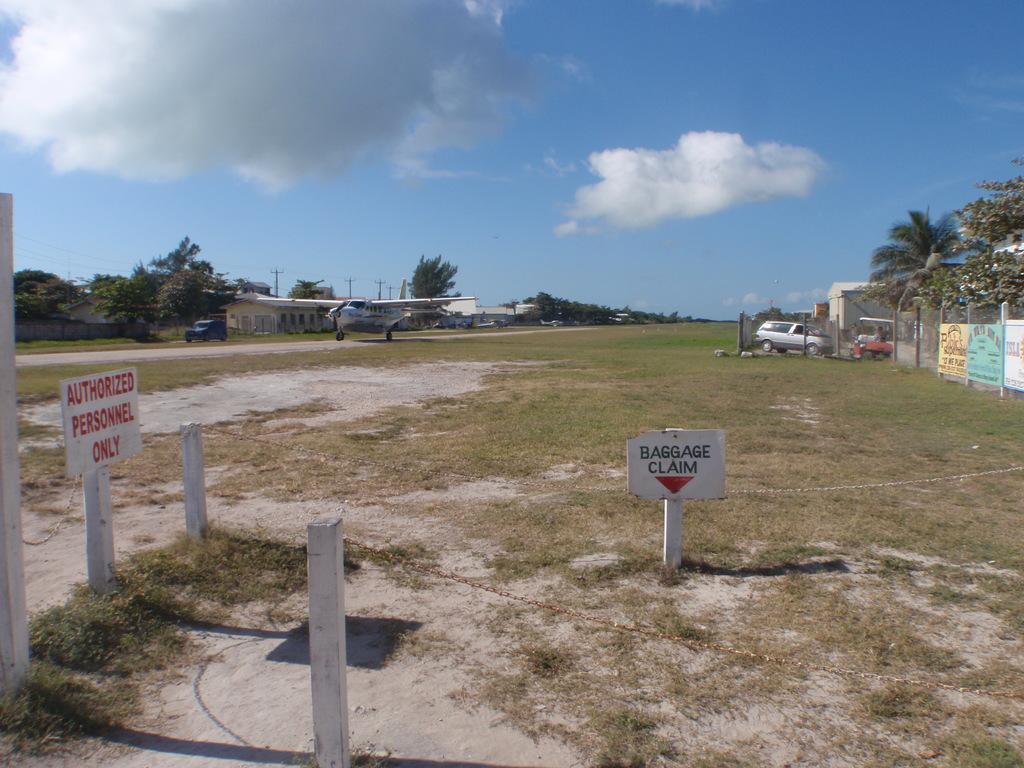How would you summarize this image in a sentence or two? In this image I can see few white colored poles, two boards attached to the poles and some grass on the ground. In the background I can see an aircraft, few vehicles on the ground, the wall, the fencing, few trees, few buildings, few poles and the sky. 